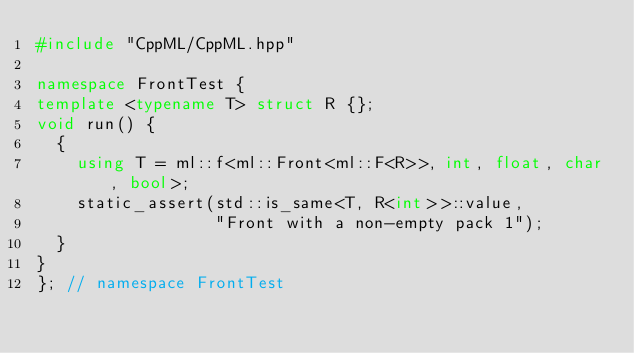<code> <loc_0><loc_0><loc_500><loc_500><_C++_>#include "CppML/CppML.hpp"

namespace FrontTest {
template <typename T> struct R {};
void run() {
  {
    using T = ml::f<ml::Front<ml::F<R>>, int, float, char, bool>;
    static_assert(std::is_same<T, R<int>>::value,
                  "Front with a non-empty pack 1");
  }
}
}; // namespace FrontTest
</code> 